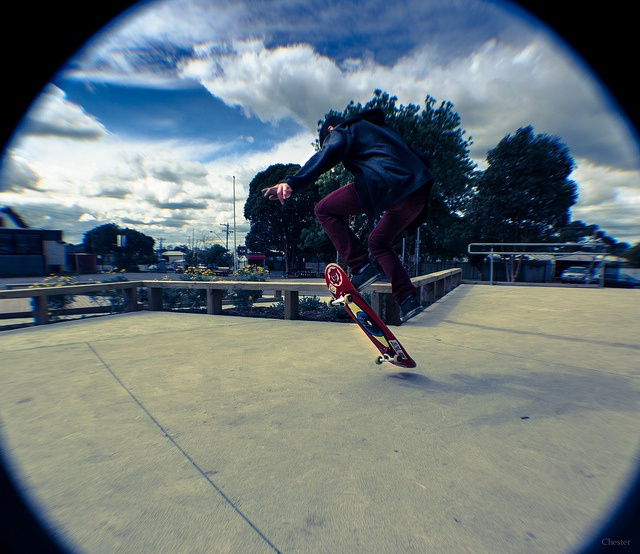Describe the objects in this image and their specific colors. I can see people in black, navy, blue, and purple tones, bench in black, gray, navy, and darkblue tones, skateboard in black, maroon, navy, and gray tones, car in black, navy, and blue tones, and car in black, navy, blue, and gray tones in this image. 